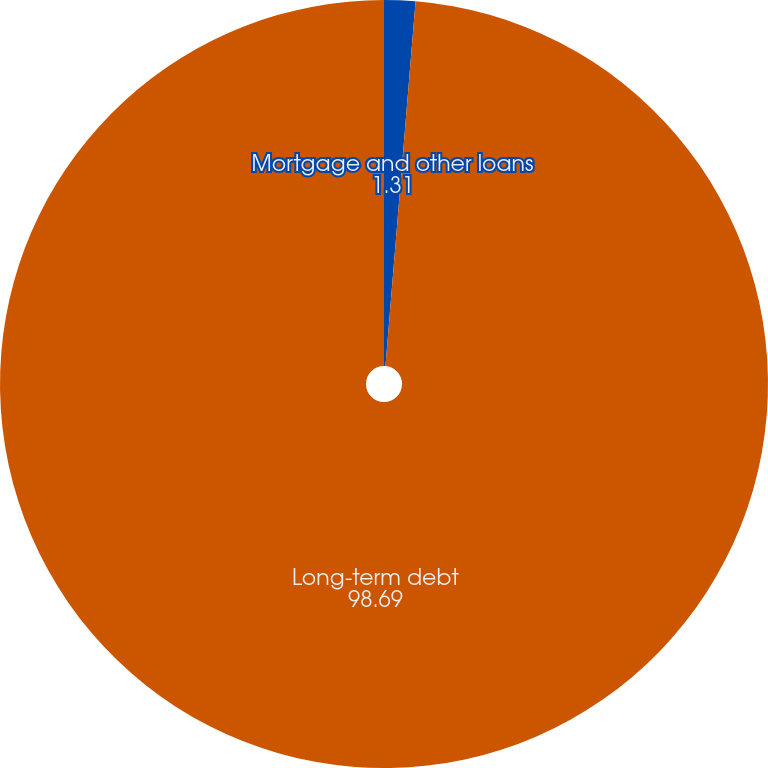Convert chart. <chart><loc_0><loc_0><loc_500><loc_500><pie_chart><fcel>Mortgage and other loans<fcel>Long-term debt<nl><fcel>1.31%<fcel>98.69%<nl></chart> 